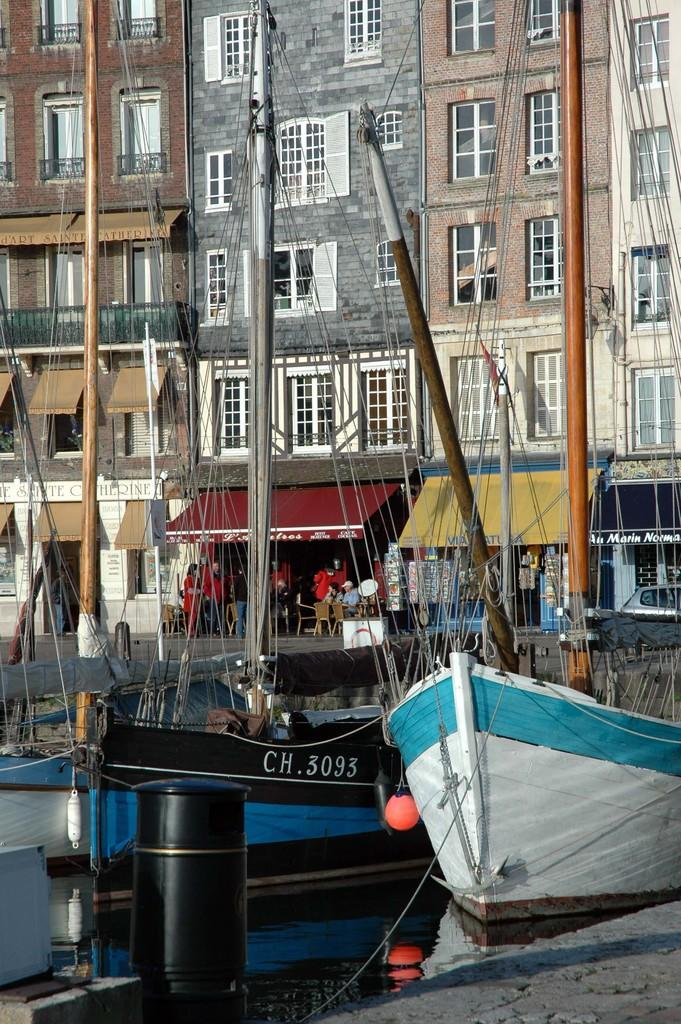What is on the water surface in the image? There are boats on the water surface in the image. What can be seen in the foreground area of the image? There is a small pole and ropes in the foreground area of the image. What is visible in the background of the image? There are stalls, buildings, and poles in the background of the image. Are there any people present in the image? Yes, there are people in the background of the image. What time of day is it in the image, based on the hour? The provided facts do not mention the time of day or any hour, so it cannot be determined from the image. Can you see any mice in the image? There are no mice present in the image. 